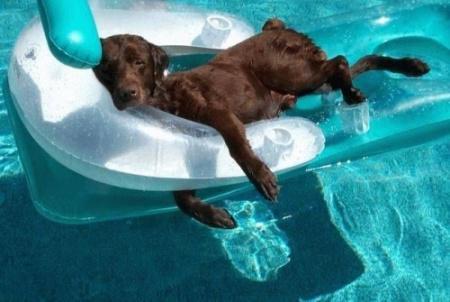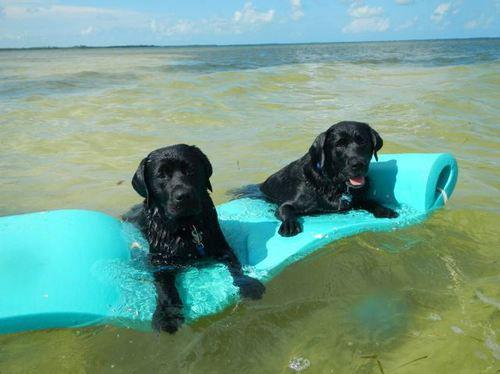The first image is the image on the left, the second image is the image on the right. Examine the images to the left and right. Is the description "A black dog is floating on something yellow in a pool." accurate? Answer yes or no. No. The first image is the image on the left, the second image is the image on the right. Considering the images on both sides, is "One dog is swimming." valid? Answer yes or no. No. 